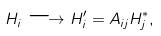Convert formula to latex. <formula><loc_0><loc_0><loc_500><loc_500>H _ { i } \longrightarrow H ^ { \prime } _ { i } = A _ { i j } H ^ { \ast } _ { j } ,</formula> 